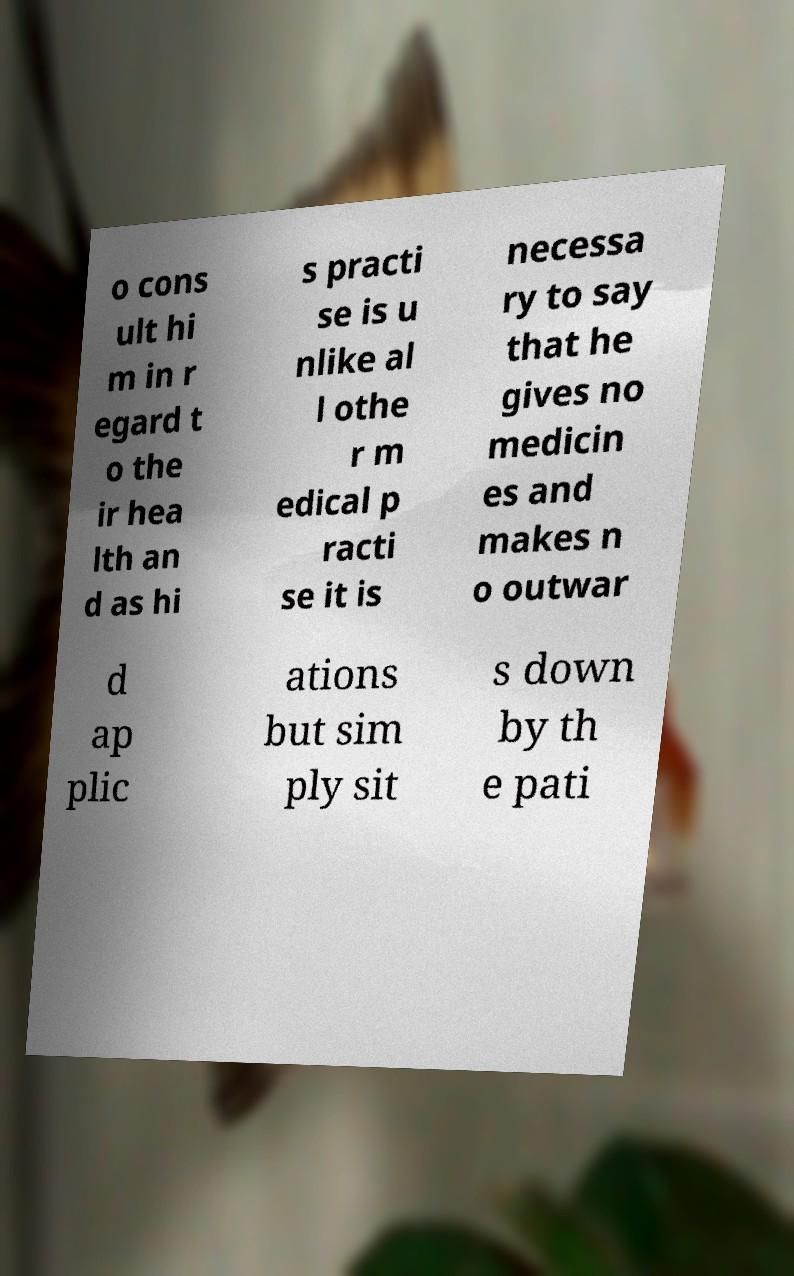For documentation purposes, I need the text within this image transcribed. Could you provide that? o cons ult hi m in r egard t o the ir hea lth an d as hi s practi se is u nlike al l othe r m edical p racti se it is necessa ry to say that he gives no medicin es and makes n o outwar d ap plic ations but sim ply sit s down by th e pati 